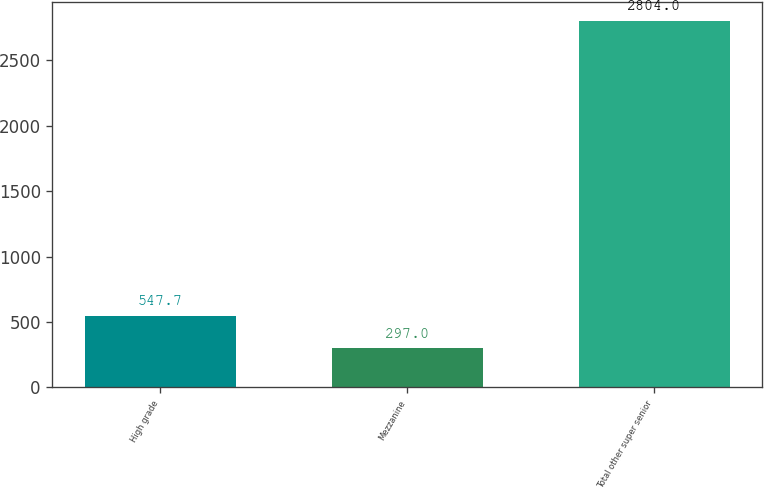<chart> <loc_0><loc_0><loc_500><loc_500><bar_chart><fcel>High grade<fcel>Mezzanine<fcel>Total other super senior<nl><fcel>547.7<fcel>297<fcel>2804<nl></chart> 